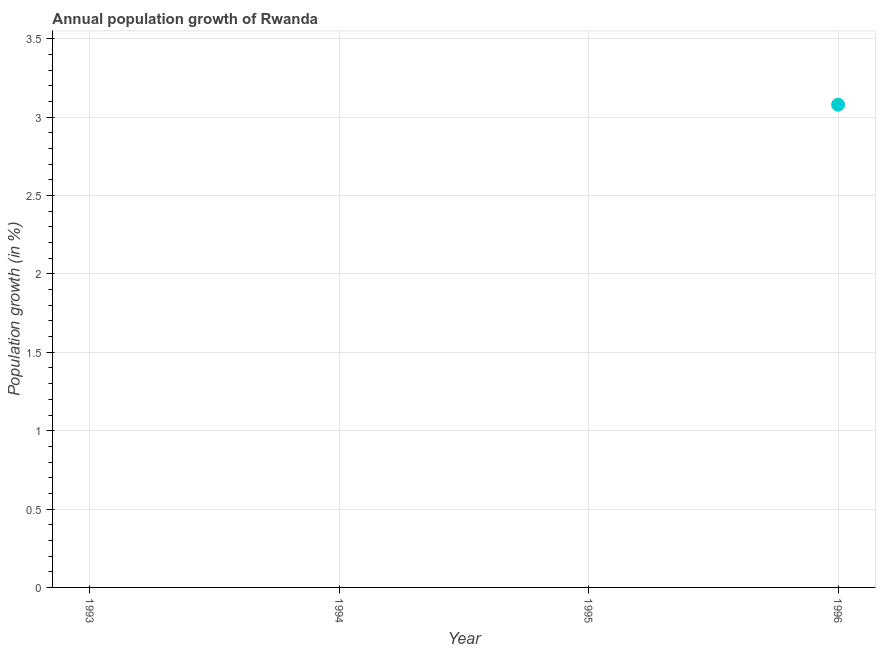Across all years, what is the maximum population growth?
Keep it short and to the point. 3.08. Across all years, what is the minimum population growth?
Your answer should be very brief. 0. In which year was the population growth maximum?
Provide a succinct answer. 1996. What is the sum of the population growth?
Your answer should be very brief. 3.08. What is the average population growth per year?
Your answer should be compact. 0.77. What is the median population growth?
Your answer should be compact. 0. In how many years, is the population growth greater than 2.9 %?
Offer a very short reply. 1. What is the difference between the highest and the lowest population growth?
Your answer should be compact. 3.08. In how many years, is the population growth greater than the average population growth taken over all years?
Provide a short and direct response. 1. How many dotlines are there?
Provide a succinct answer. 1. How many years are there in the graph?
Offer a terse response. 4. What is the difference between two consecutive major ticks on the Y-axis?
Provide a succinct answer. 0.5. Are the values on the major ticks of Y-axis written in scientific E-notation?
Provide a succinct answer. No. Does the graph contain grids?
Give a very brief answer. Yes. What is the title of the graph?
Your answer should be very brief. Annual population growth of Rwanda. What is the label or title of the Y-axis?
Offer a very short reply. Population growth (in %). What is the Population growth (in %) in 1993?
Your response must be concise. 0. What is the Population growth (in %) in 1994?
Give a very brief answer. 0. What is the Population growth (in %) in 1996?
Keep it short and to the point. 3.08. 